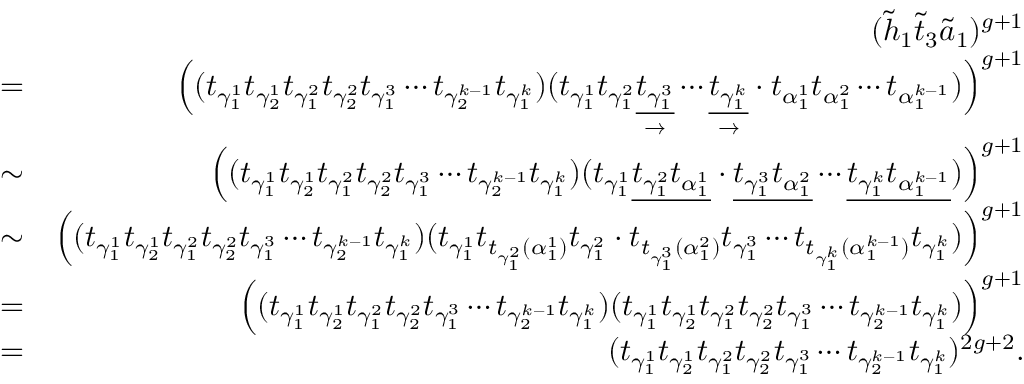Convert formula to latex. <formula><loc_0><loc_0><loc_500><loc_500>\begin{array} { r l r } & { ( \widetilde { h } _ { 1 } \widetilde { t } _ { 3 } \widetilde { a } _ { 1 } ) ^ { g + 1 } } \\ & { = } & { \left ( ( t _ { \gamma _ { 1 } ^ { 1 } } t _ { \gamma _ { 2 } ^ { 1 } } t _ { \gamma _ { 1 } ^ { 2 } } t _ { \gamma _ { 2 } ^ { 2 } } t _ { \gamma _ { 1 } ^ { 3 } } \cdots t _ { \gamma _ { 2 } ^ { k - 1 } } t _ { \gamma _ { 1 } ^ { k } } ) ( t _ { \gamma _ { 1 } ^ { 1 } } t _ { \gamma _ { 1 } ^ { 2 } } \underset { \rightarrow } { \underline { { t _ { \gamma _ { 1 } ^ { 3 } } } } } \cdots \underset { \rightarrow } { \underline { { t _ { \gamma _ { 1 } ^ { k } } } } } \cdot t _ { \alpha _ { 1 } ^ { 1 } } t _ { \alpha _ { 1 } ^ { 2 } } \cdots t _ { \alpha _ { 1 } ^ { k - 1 } } ) \right ) ^ { g + 1 } } \\ & { \sim } & { \left ( ( t _ { \gamma _ { 1 } ^ { 1 } } t _ { \gamma _ { 2 } ^ { 1 } } t _ { \gamma _ { 1 } ^ { 2 } } t _ { \gamma _ { 2 } ^ { 2 } } t _ { \gamma _ { 1 } ^ { 3 } } \cdots t _ { \gamma _ { 2 } ^ { k - 1 } } t _ { \gamma _ { 1 } ^ { k } } ) ( t _ { \gamma _ { 1 } ^ { 1 } } \underline { { t _ { \gamma _ { 1 } ^ { 2 } } t _ { \alpha _ { 1 } ^ { 1 } } } } \cdot \underline { { t _ { \gamma _ { 1 } ^ { 3 } } t _ { \alpha _ { 1 } ^ { 2 } } } } \cdots \underline { { t _ { \gamma _ { 1 } ^ { k } } t _ { \alpha _ { 1 } ^ { k - 1 } } } } ) \right ) ^ { g + 1 } } \\ & { \sim } & { \left ( ( t _ { \gamma _ { 1 } ^ { 1 } } t _ { \gamma _ { 2 } ^ { 1 } } t _ { \gamma _ { 1 } ^ { 2 } } t _ { \gamma _ { 2 } ^ { 2 } } t _ { \gamma _ { 1 } ^ { 3 } } \cdots t _ { \gamma _ { 2 } ^ { k - 1 } } t _ { \gamma _ { 1 } ^ { k } } ) ( t _ { \gamma _ { 1 } ^ { 1 } } t _ { t _ { \gamma _ { 1 } ^ { 2 } } ( \alpha _ { 1 } ^ { 1 } ) } t _ { \gamma _ { 1 } ^ { 2 } } \cdot t _ { t _ { \gamma _ { 1 } ^ { 3 } } ( \alpha _ { 1 } ^ { 2 } ) } t _ { \gamma _ { 1 } ^ { 3 } } \cdots t _ { t _ { \gamma _ { 1 } ^ { k } } ( \alpha _ { 1 } ^ { k - 1 } ) } t _ { \gamma _ { 1 } ^ { k } } ) \right ) ^ { g + 1 } } \\ & { = } & { \left ( ( t _ { \gamma _ { 1 } ^ { 1 } } t _ { \gamma _ { 2 } ^ { 1 } } t _ { \gamma _ { 1 } ^ { 2 } } t _ { \gamma _ { 2 } ^ { 2 } } t _ { \gamma _ { 1 } ^ { 3 } } \cdots t _ { \gamma _ { 2 } ^ { k - 1 } } t _ { \gamma _ { 1 } ^ { k } } ) ( t _ { \gamma _ { 1 } ^ { 1 } } t _ { \gamma _ { 2 } ^ { 1 } } t _ { \gamma _ { 1 } ^ { 2 } } t _ { \gamma _ { 2 } ^ { 2 } } t _ { \gamma _ { 1 } ^ { 3 } } \cdots t _ { \gamma _ { 2 } ^ { k - 1 } } t _ { \gamma _ { 1 } ^ { k } } ) \right ) ^ { g + 1 } } \\ & { = } & { ( t _ { \gamma _ { 1 } ^ { 1 } } t _ { \gamma _ { 2 } ^ { 1 } } t _ { \gamma _ { 1 } ^ { 2 } } t _ { \gamma _ { 2 } ^ { 2 } } t _ { \gamma _ { 1 } ^ { 3 } } \cdots t _ { \gamma _ { 2 } ^ { k - 1 } } t _ { \gamma _ { 1 } ^ { k } } ) ^ { 2 g + 2 } . } \end{array}</formula> 